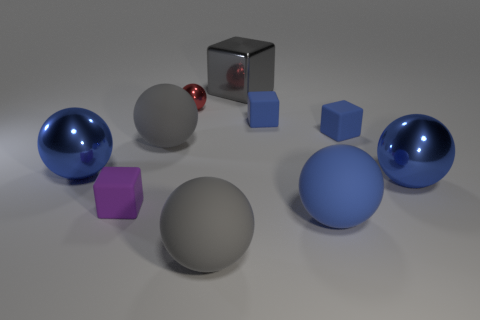Subtract all blue spheres. How many were subtracted if there are1blue spheres left? 2 Subtract all yellow cylinders. How many blue balls are left? 3 Subtract 3 spheres. How many spheres are left? 3 Subtract all red balls. How many balls are left? 5 Subtract all tiny balls. How many balls are left? 5 Subtract all brown balls. Subtract all purple blocks. How many balls are left? 6 Subtract all cubes. How many objects are left? 6 Subtract all spheres. Subtract all large blue balls. How many objects are left? 1 Add 4 red objects. How many red objects are left? 5 Add 5 tiny purple rubber things. How many tiny purple rubber things exist? 6 